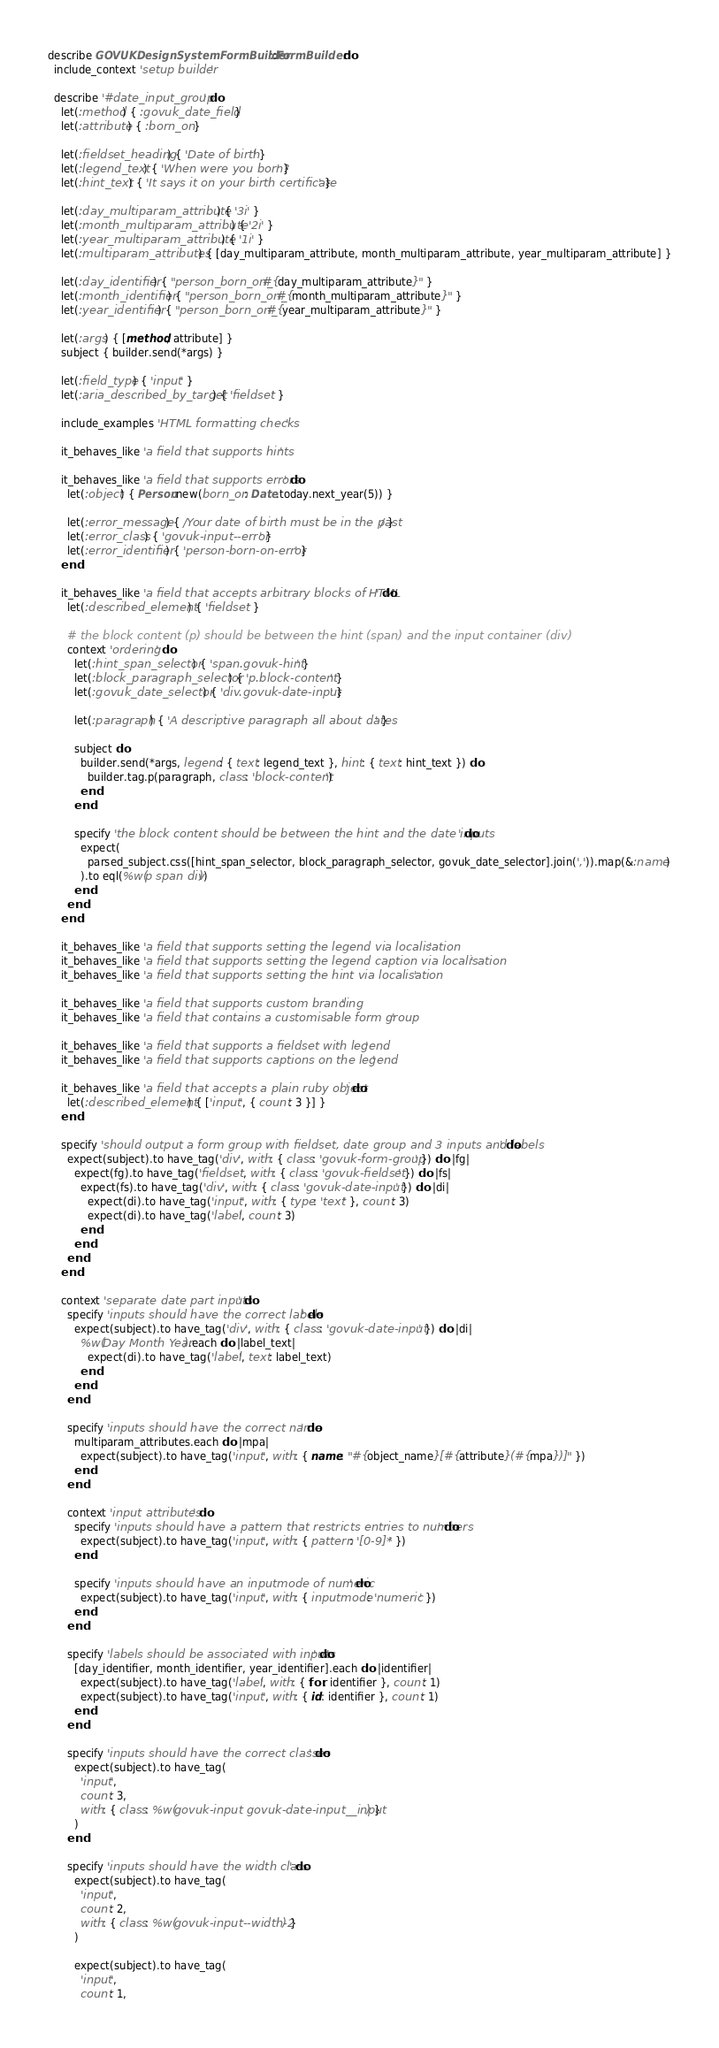<code> <loc_0><loc_0><loc_500><loc_500><_Ruby_>describe GOVUKDesignSystemFormBuilder::FormBuilder do
  include_context 'setup builder'

  describe '#date_input_group' do
    let(:method) { :govuk_date_field }
    let(:attribute) { :born_on }

    let(:fieldset_heading) { 'Date of birth' }
    let(:legend_text) { 'When were you born?' }
    let(:hint_text) { 'It says it on your birth certificate' }

    let(:day_multiparam_attribute) { '3i' }
    let(:month_multiparam_attribute) { '2i' }
    let(:year_multiparam_attribute) { '1i' }
    let(:multiparam_attributes) { [day_multiparam_attribute, month_multiparam_attribute, year_multiparam_attribute] }

    let(:day_identifier) { "person_born_on_#{day_multiparam_attribute}" }
    let(:month_identifier) { "person_born_on_#{month_multiparam_attribute}" }
    let(:year_identifier) { "person_born_on_#{year_multiparam_attribute}" }

    let(:args) { [method, attribute] }
    subject { builder.send(*args) }

    let(:field_type) { 'input' }
    let(:aria_described_by_target) { 'fieldset' }

    include_examples 'HTML formatting checks'

    it_behaves_like 'a field that supports hints'

    it_behaves_like 'a field that supports errors' do
      let(:object) { Person.new(born_on: Date.today.next_year(5)) }

      let(:error_message) { /Your date of birth must be in the past/ }
      let(:error_class) { 'govuk-input--error' }
      let(:error_identifier) { 'person-born-on-error' }
    end

    it_behaves_like 'a field that accepts arbitrary blocks of HTML' do
      let(:described_element) { 'fieldset' }

      # the block content (p) should be between the hint (span) and the input container (div)
      context 'ordering' do
        let(:hint_span_selector) { 'span.govuk-hint' }
        let(:block_paragraph_selector) { 'p.block-content' }
        let(:govuk_date_selector) { 'div.govuk-date-input' }

        let(:paragraph) { 'A descriptive paragraph all about dates' }

        subject do
          builder.send(*args, legend: { text: legend_text }, hint: { text: hint_text }) do
            builder.tag.p(paragraph, class: 'block-content')
          end
        end

        specify 'the block content should be between the hint and the date inputs' do
          expect(
            parsed_subject.css([hint_span_selector, block_paragraph_selector, govuk_date_selector].join(',')).map(&:name)
          ).to eql(%w(p span div))
        end
      end
    end

    it_behaves_like 'a field that supports setting the legend via localisation'
    it_behaves_like 'a field that supports setting the legend caption via localisation'
    it_behaves_like 'a field that supports setting the hint via localisation'

    it_behaves_like 'a field that supports custom branding'
    it_behaves_like 'a field that contains a customisable form group'

    it_behaves_like 'a field that supports a fieldset with legend'
    it_behaves_like 'a field that supports captions on the legend'

    it_behaves_like 'a field that accepts a plain ruby object' do
      let(:described_element) { ['input', { count: 3 }] }
    end

    specify 'should output a form group with fieldset, date group and 3 inputs and labels' do
      expect(subject).to have_tag('div', with: { class: 'govuk-form-group' }) do |fg|
        expect(fg).to have_tag('fieldset', with: { class: 'govuk-fieldset' }) do |fs|
          expect(fs).to have_tag('div', with: { class: 'govuk-date-input' }) do |di|
            expect(di).to have_tag('input', with: { type: 'text' }, count: 3)
            expect(di).to have_tag('label', count: 3)
          end
        end
      end
    end

    context 'separate date part inputs' do
      specify 'inputs should have the correct labels' do
        expect(subject).to have_tag('div', with: { class: 'govuk-date-input' }) do |di|
          %w(Day Month Year).each do |label_text|
            expect(di).to have_tag('label', text: label_text)
          end
        end
      end

      specify 'inputs should have the correct name' do
        multiparam_attributes.each do |mpa|
          expect(subject).to have_tag('input', with: { name: "#{object_name}[#{attribute}(#{mpa})]" })
        end
      end

      context 'input attributes' do
        specify 'inputs should have a pattern that restricts entries to numbers' do
          expect(subject).to have_tag('input', with: { pattern: '[0-9]*' })
        end

        specify 'inputs should have an inputmode of numeric' do
          expect(subject).to have_tag('input', with: { inputmode: 'numeric' })
        end
      end

      specify 'labels should be associated with inputs' do
        [day_identifier, month_identifier, year_identifier].each do |identifier|
          expect(subject).to have_tag('label', with: { for: identifier }, count: 1)
          expect(subject).to have_tag('input', with: { id: identifier }, count: 1)
        end
      end

      specify 'inputs should have the correct classes' do
        expect(subject).to have_tag(
          'input',
          count: 3,
          with: { class: %w(govuk-input govuk-date-input__input) }
        )
      end

      specify 'inputs should have the width class' do
        expect(subject).to have_tag(
          'input',
          count: 2,
          with: { class: %w(govuk-input--width-2) }
        )

        expect(subject).to have_tag(
          'input',
          count: 1,</code> 